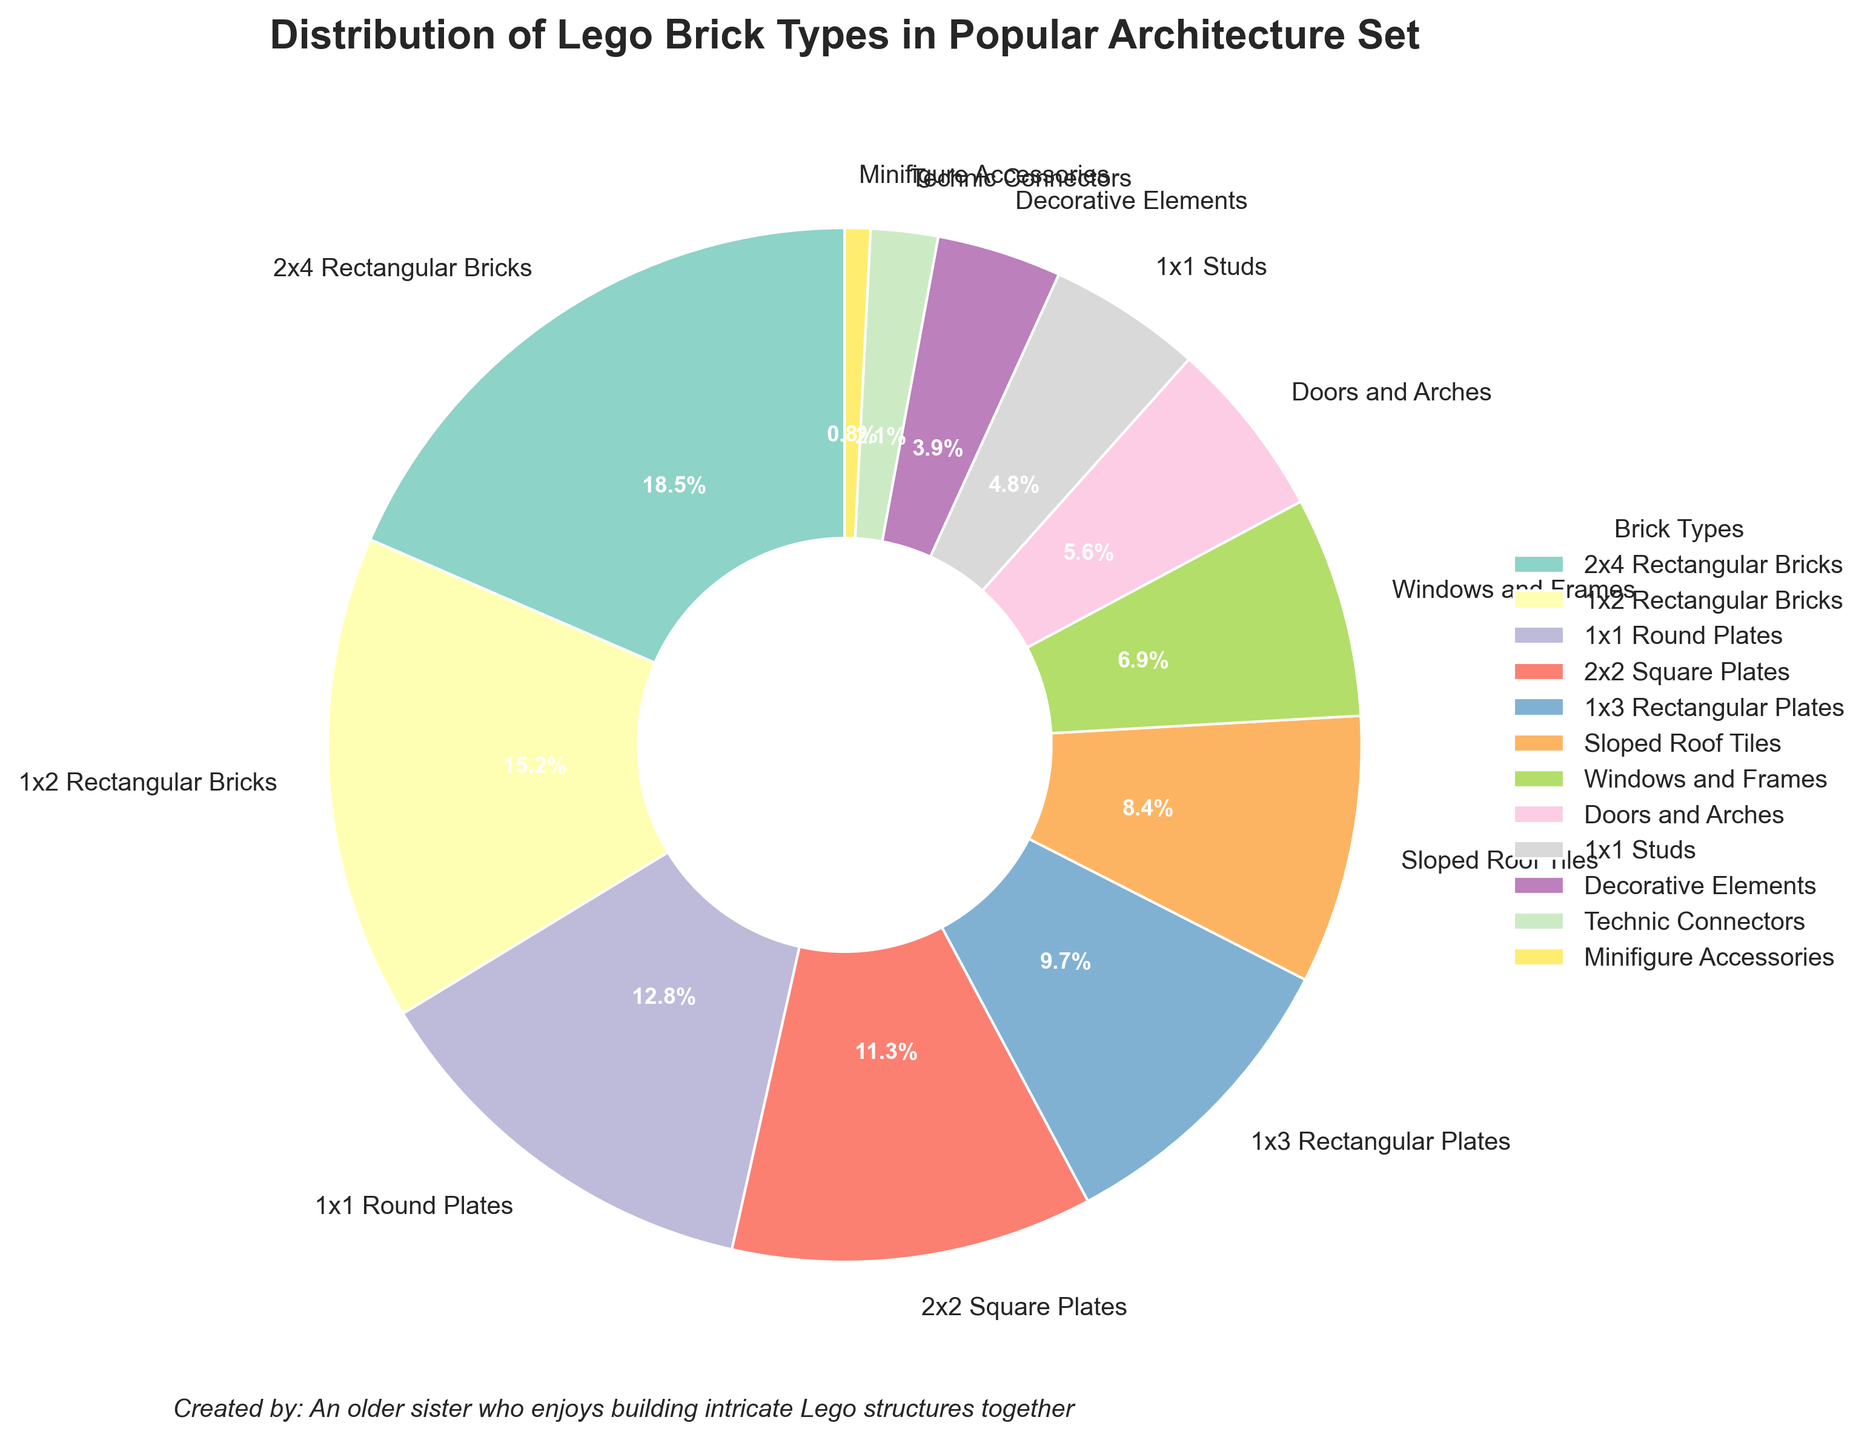What percentage of bricks are Decorative Elements? The pie chart shows a segment labeled Decorative Elements with a percentage value beside it.
Answer: 3.9% Which type of Lego bricks have the largest percentage in the architecture set? The largest segment in the pie chart corresponds to the 2x4 Rectangular Bricks.
Answer: 2x4 Rectangular Bricks How much more percentage do 2x4 Rectangular Bricks have compared to 1x1 Studs? The percentage for 2x4 Rectangular Bricks is 18.5%, and for 1x1 Studs, it is 4.8%. Subtract 4.8% from 18.5%.
Answer: 13.7% What is the combined percentage of 1x3 Rectangular Plates and Sloped Roof Tiles? The percentage for 1x3 Rectangular Plates is 9.7%, and for Sloped Roof Tiles, it is 8.4%. Add these two percentages together.
Answer: 18.1% Which brick type has a lower percentage: Technic Connectors or Windows and Frames? The pie chart shows Technic Connectors at 2.1% and Windows and Frames at 6.9%. 2.1% is less than 6.9%.
Answer: Technic Connectors Is the percentage of 1x1 Round Plates higher than that of Sloped Roof Tiles? The pie chart shows 1x1 Round Plates at 12.8% and Sloped Roof Tiles at 8.4%. 12.8% is greater than 8.4%.
Answer: Yes Among the brick types, which sections appear to be almost the same size visually? The segments for 2x4 Rectangular Bricks at 18.5% and 1x2 Rectangular Bricks at 15.2% look visually distinct in size, but the segments for Technic Connectors at 2.1% and Minifigure Accessories at 0.8% appear relatively similar.
Answer: Technic Connectors and Minifigure Accessories 